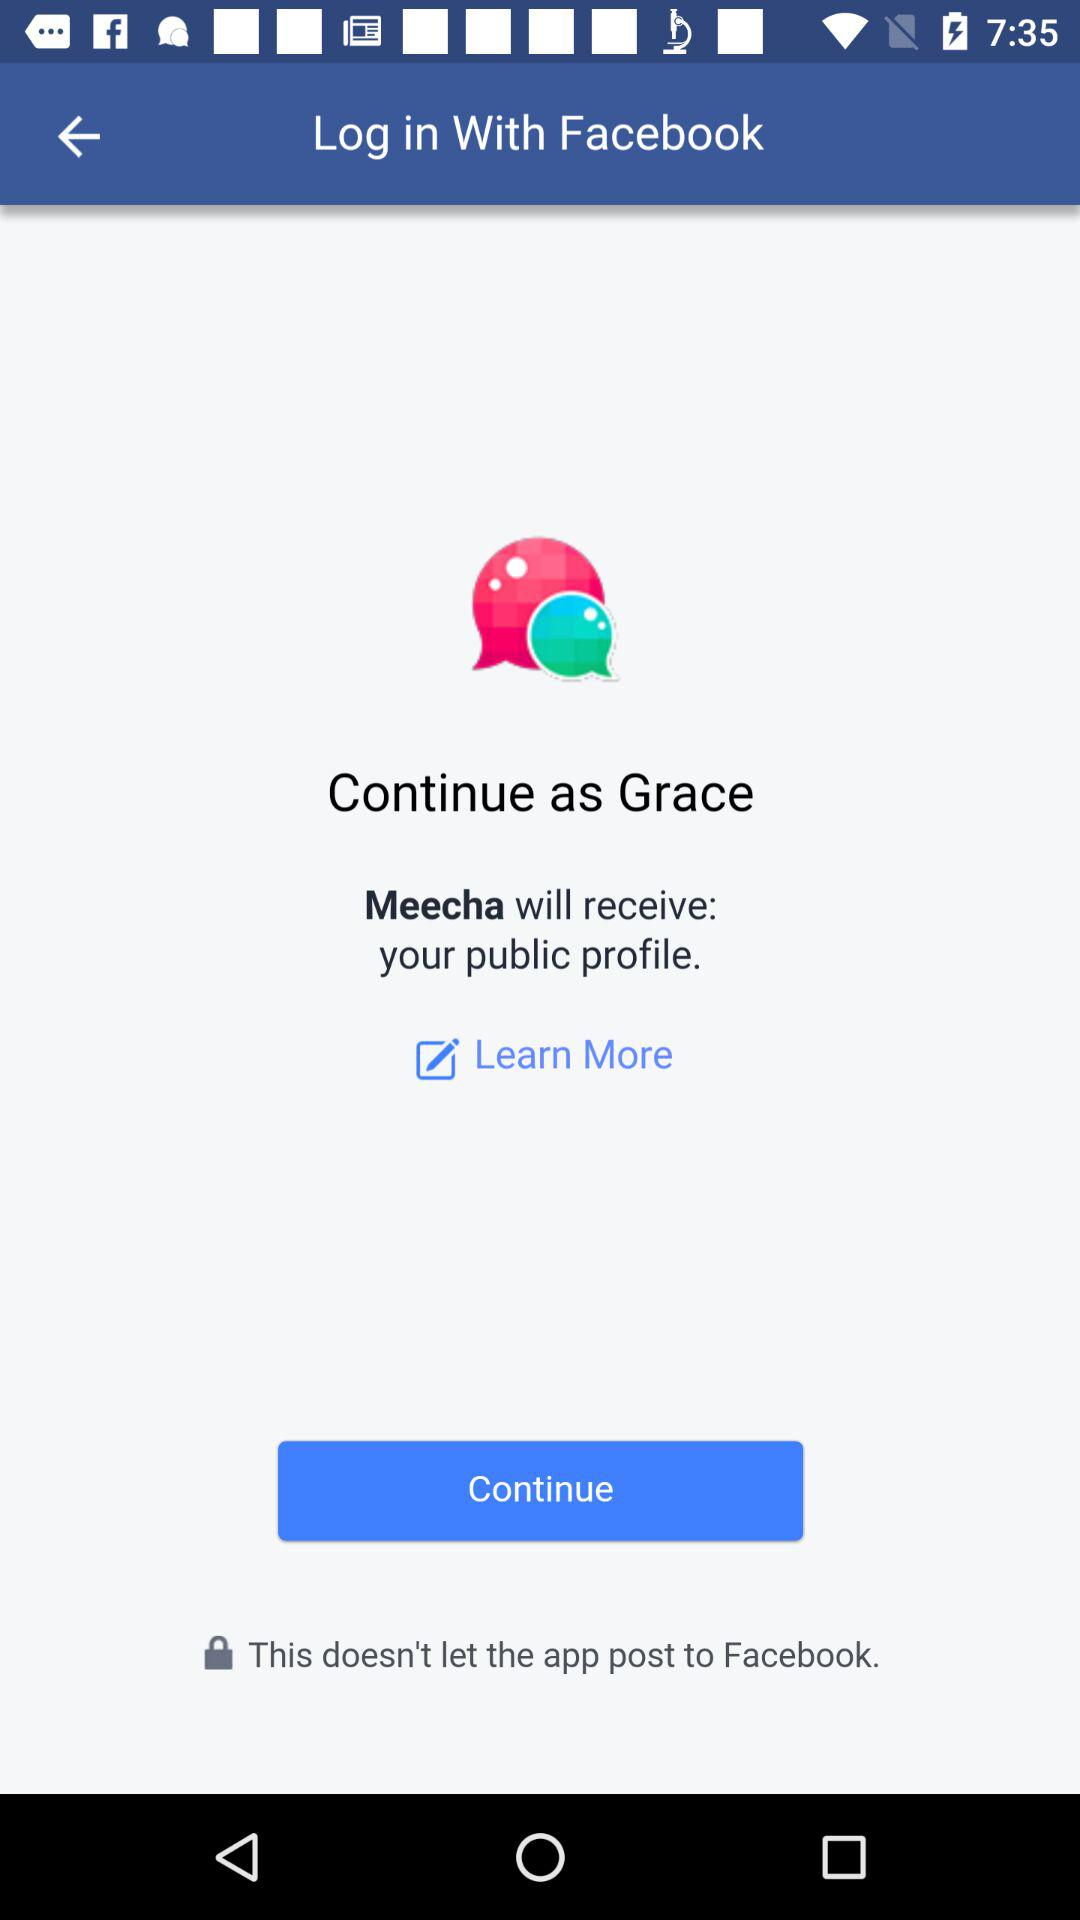What is the login name? The login name is Grace. 